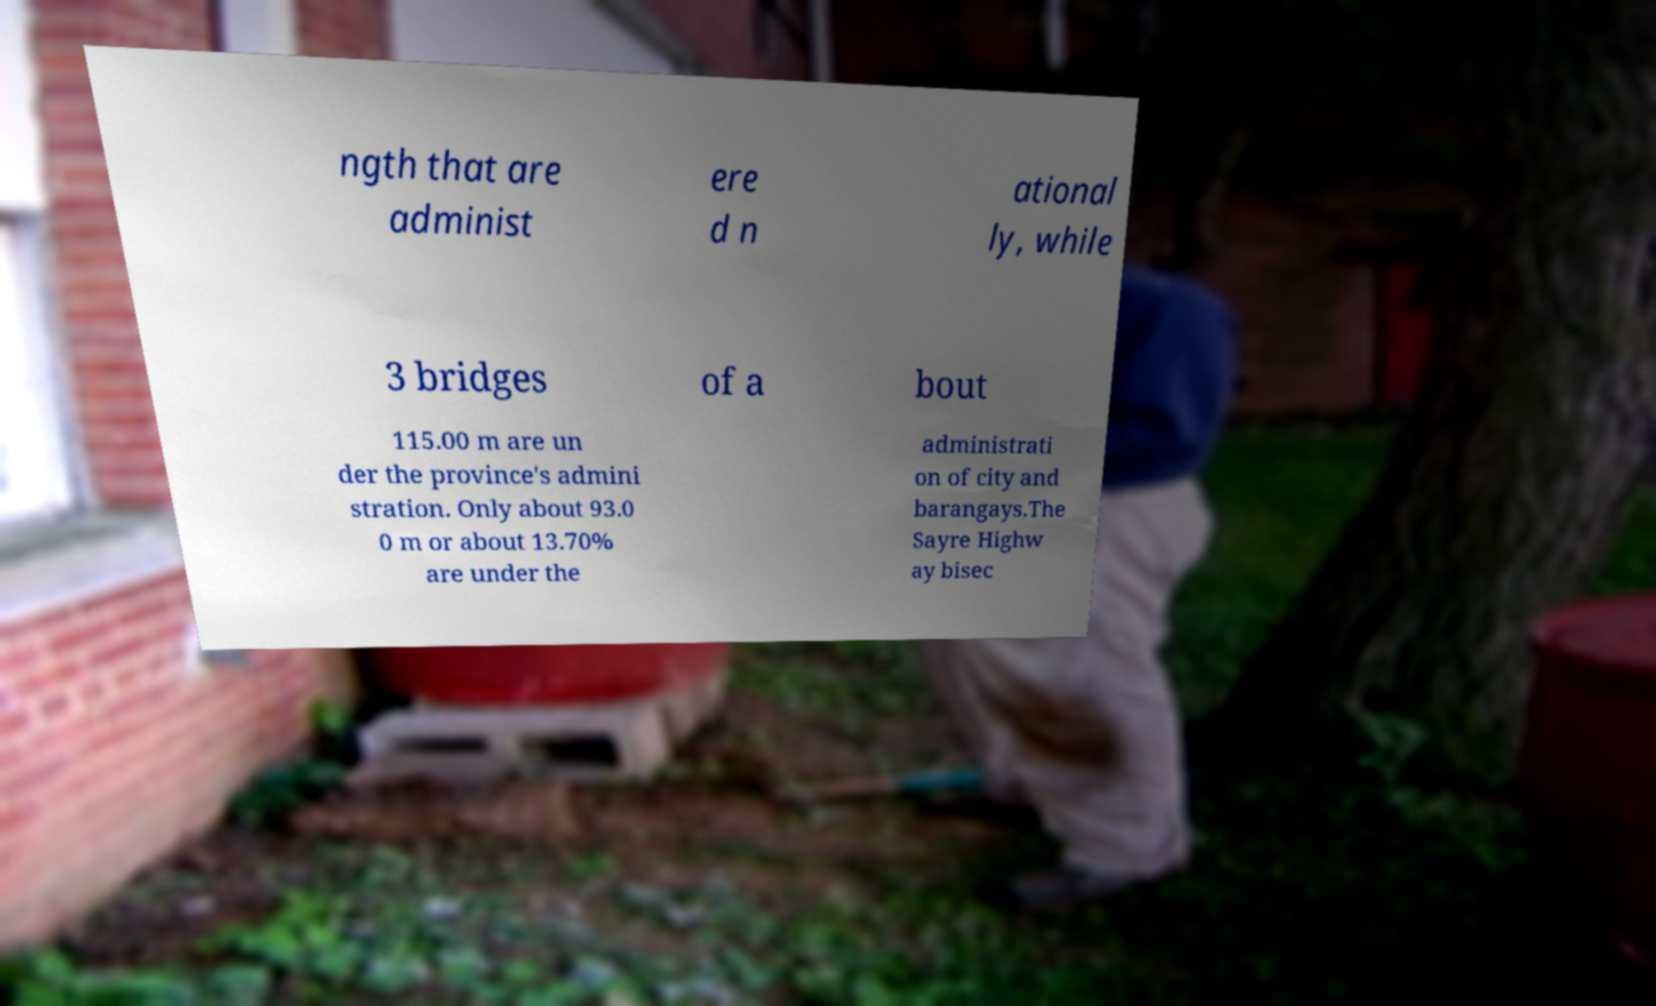Please identify and transcribe the text found in this image. ngth that are administ ere d n ational ly, while 3 bridges of a bout 115.00 m are un der the province's admini stration. Only about 93.0 0 m or about 13.70% are under the administrati on of city and barangays.The Sayre Highw ay bisec 